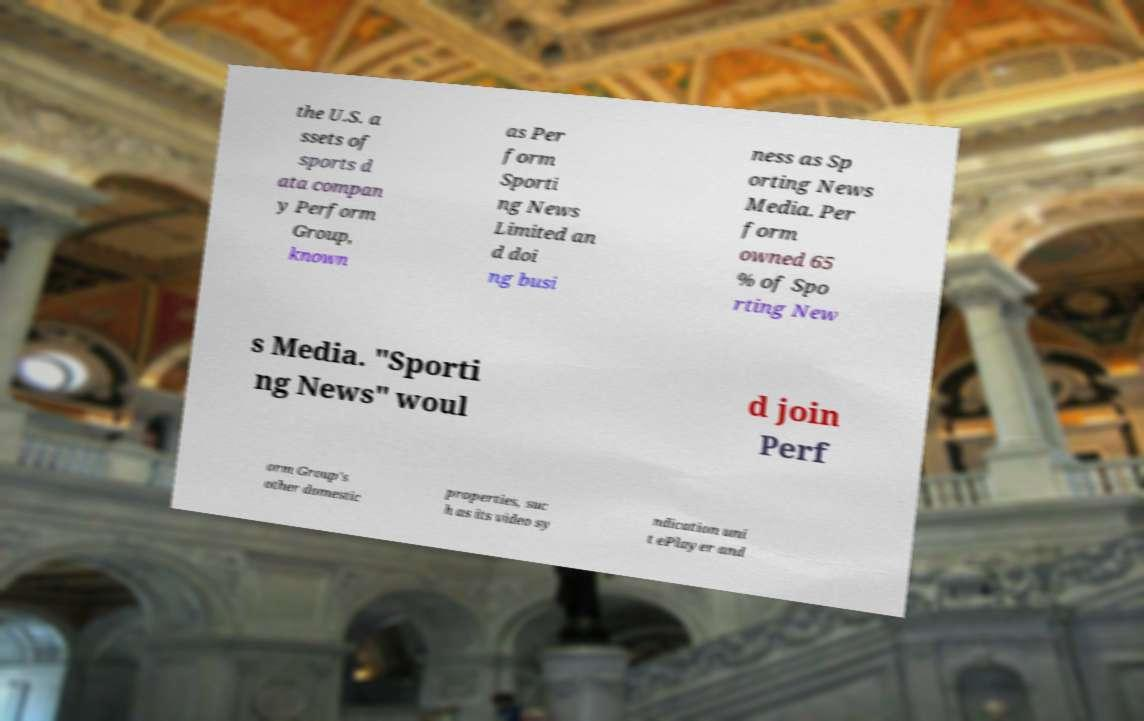There's text embedded in this image that I need extracted. Can you transcribe it verbatim? the U.S. a ssets of sports d ata compan y Perform Group, known as Per form Sporti ng News Limited an d doi ng busi ness as Sp orting News Media. Per form owned 65 % of Spo rting New s Media. "Sporti ng News" woul d join Perf orm Group's other domestic properties, suc h as its video sy ndication uni t ePlayer and 